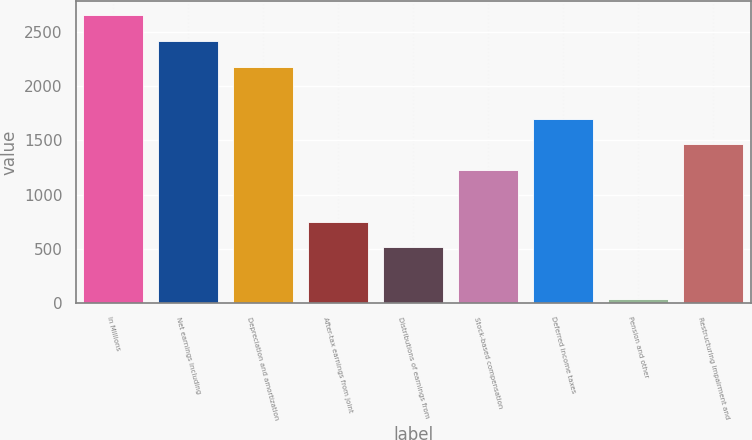Convert chart to OTSL. <chart><loc_0><loc_0><loc_500><loc_500><bar_chart><fcel>In Millions<fcel>Net earnings including<fcel>Depreciation and amortization<fcel>After-tax earnings from joint<fcel>Distributions of earnings from<fcel>Stock-based compensation<fcel>Deferred income taxes<fcel>Pension and other<fcel>Restructuring impairment and<nl><fcel>2653.15<fcel>2415.2<fcel>2177.25<fcel>749.55<fcel>511.6<fcel>1225.45<fcel>1701.35<fcel>35.7<fcel>1463.4<nl></chart> 